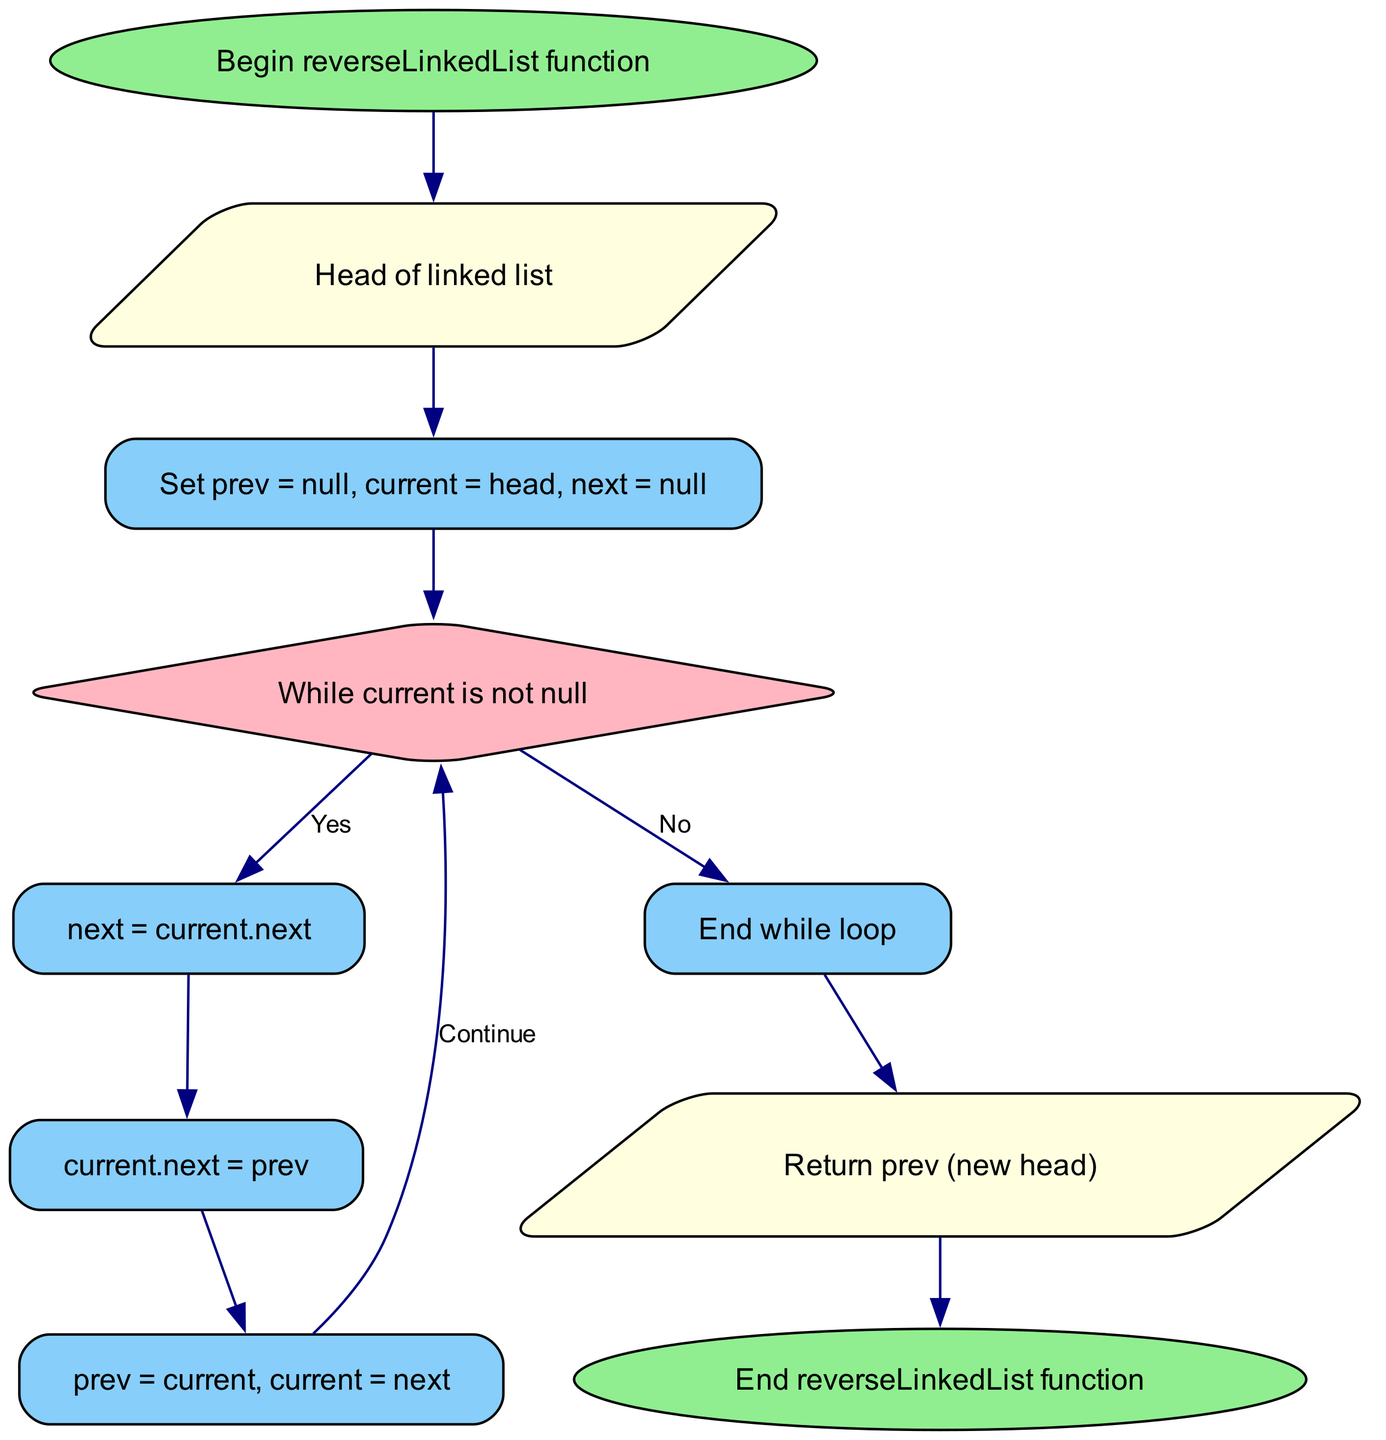What is the first step in the function? The first step in the function, as indicated in the diagram, is the "Begin reverseLinkedList function." This is represented as the starting node, leading to the input step.
Answer: Begin reverseLinkedList function What type of node is used for "Head of linked list"? In the diagram, "Head of linked list" is represented as a parallelogram, indicating it is an input node, which typically represents data input in flowcharts.
Answer: parallelogram How many actions occur inside the loop? Within the loop, there are three distinct actions that take place: storing the next node, reversing the current node's link, and moving to the next node. These actions are sequentially included in the flow, confirming their count.
Answer: three What happens when "current" is null? When "current" is null, the flowchart indicates that the process will exit the loop (End while loop) and proceed to the return statement to output the new head of the reversed linked list.
Answer: Exit to return What is returned by the function? The function returns "prev," which is the new head of the linked list after it has been reversed. This is explicitly stated in the return node of the diagram.
Answer: prev (new head) Explain the relationship between "move" and "store." The "move" step follows the "reverse" step, which comes after "store." This creates a flow where "store" saves the pointer to the next node before reversing and then "move" updates both "prev" and "current" to continue the iteration. Hence, "move" depends on the actions of "store" and "reverse."
Answer: move depends on store What colors are used for the loop control node? The loop node is colored light pink in the diagram, which distinguishes it from other nodes. The coloring helps to identify decision or control flow decisions visually.
Answer: light pink What is the final action of the function? The final action of the function, as indicated in the flowchart, is to return the new head of the reversed linked list, which is executed before the function concludes with "End reverseLinkedList function."
Answer: Return prev (new head) 